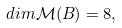<formula> <loc_0><loc_0><loc_500><loc_500>d i m \mathcal { M } ( B ) = 8 ,</formula> 